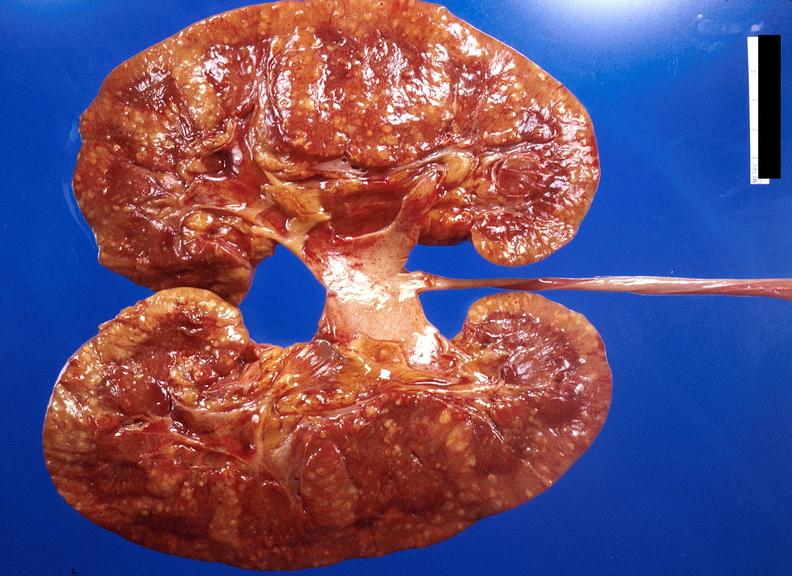where is this?
Answer the question using a single word or phrase. Urinary 